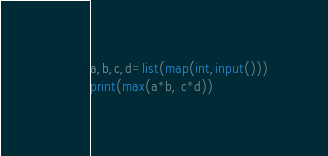<code> <loc_0><loc_0><loc_500><loc_500><_Python_>a,b,c,d=list(map(int,input()))
print(max(a*b, c*d))</code> 